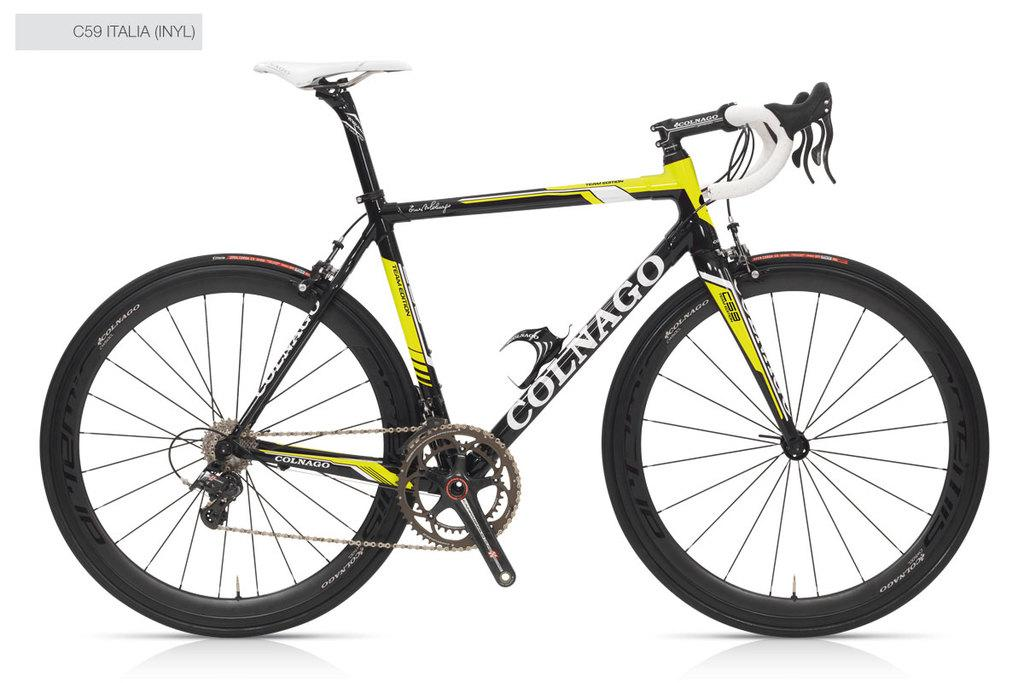What is the main subject of the image? There is a bicycle in the image. What is written at the top of the image? There is text at the top of the image. What color is the background of the image? The background of the image is white. How many nerves can be seen on the edge of the bicycle in the image? There are no nerves visible in the image, as it features a bicycle and text on a white background. 